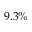Convert formula to latex. <formula><loc_0><loc_0><loc_500><loc_500>9 . 3 \%</formula> 